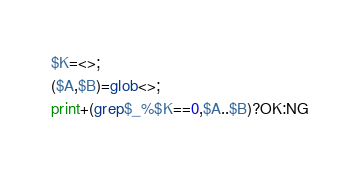<code> <loc_0><loc_0><loc_500><loc_500><_Perl_>$K=<>;
($A,$B)=glob<>;
print+(grep$_%$K==0,$A..$B)?OK:NG
</code> 